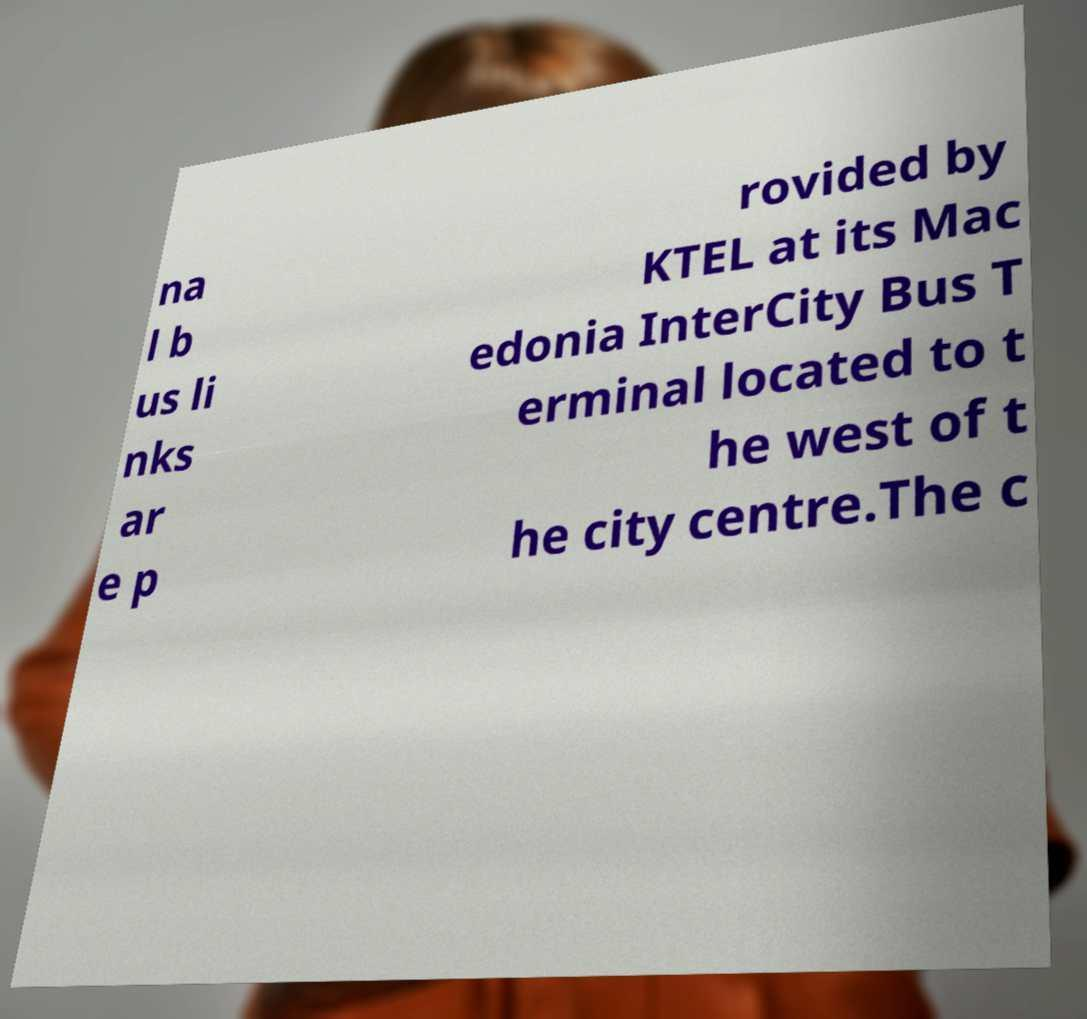For documentation purposes, I need the text within this image transcribed. Could you provide that? na l b us li nks ar e p rovided by KTEL at its Mac edonia InterCity Bus T erminal located to t he west of t he city centre.The c 